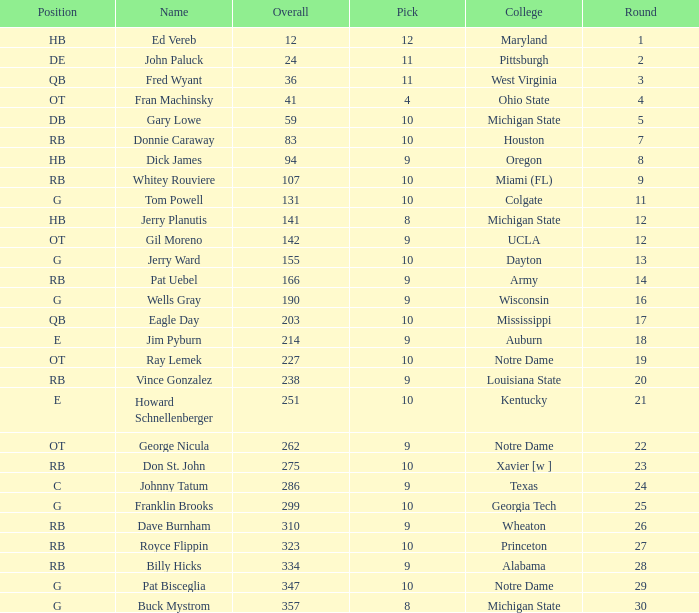What is the total number of overall picks that were after pick 9 and went to Auburn College? 0.0. 